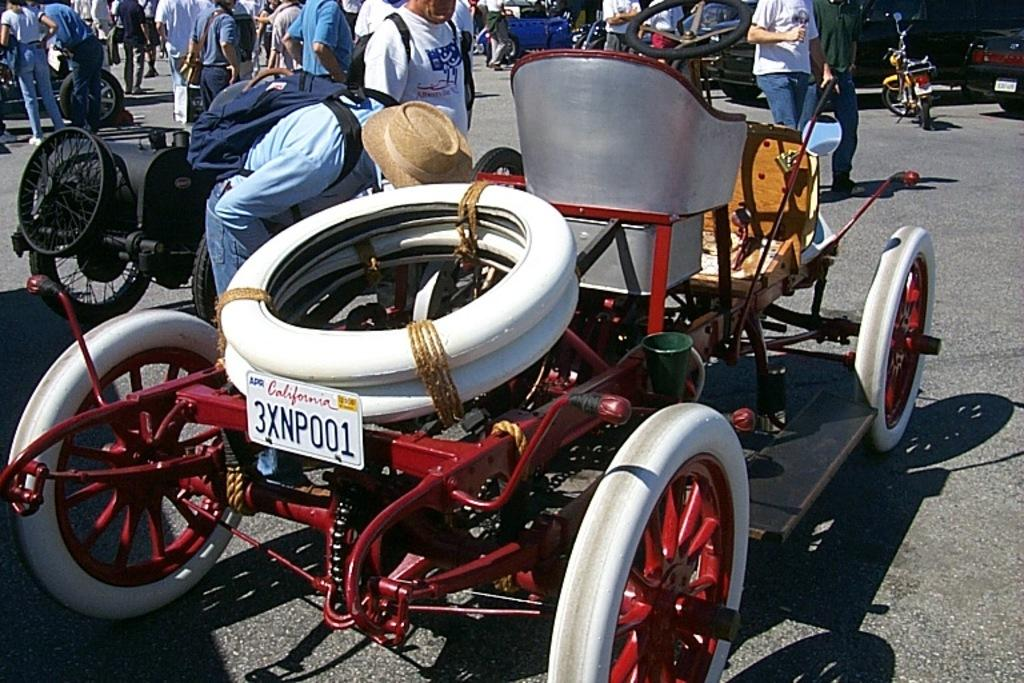What is the main subject of the image? The main subject of the image is a group of people. Can you describe the appearance of some people in the group? Some people in the group are wearing bags. What else can be seen in the image besides the group of people? There are vehicles visible on the road in the image. What type of stitch is being used to repair the vessel in the image? There is no vessel or stitching present in the image; it features a group of people and vehicles on the road. 